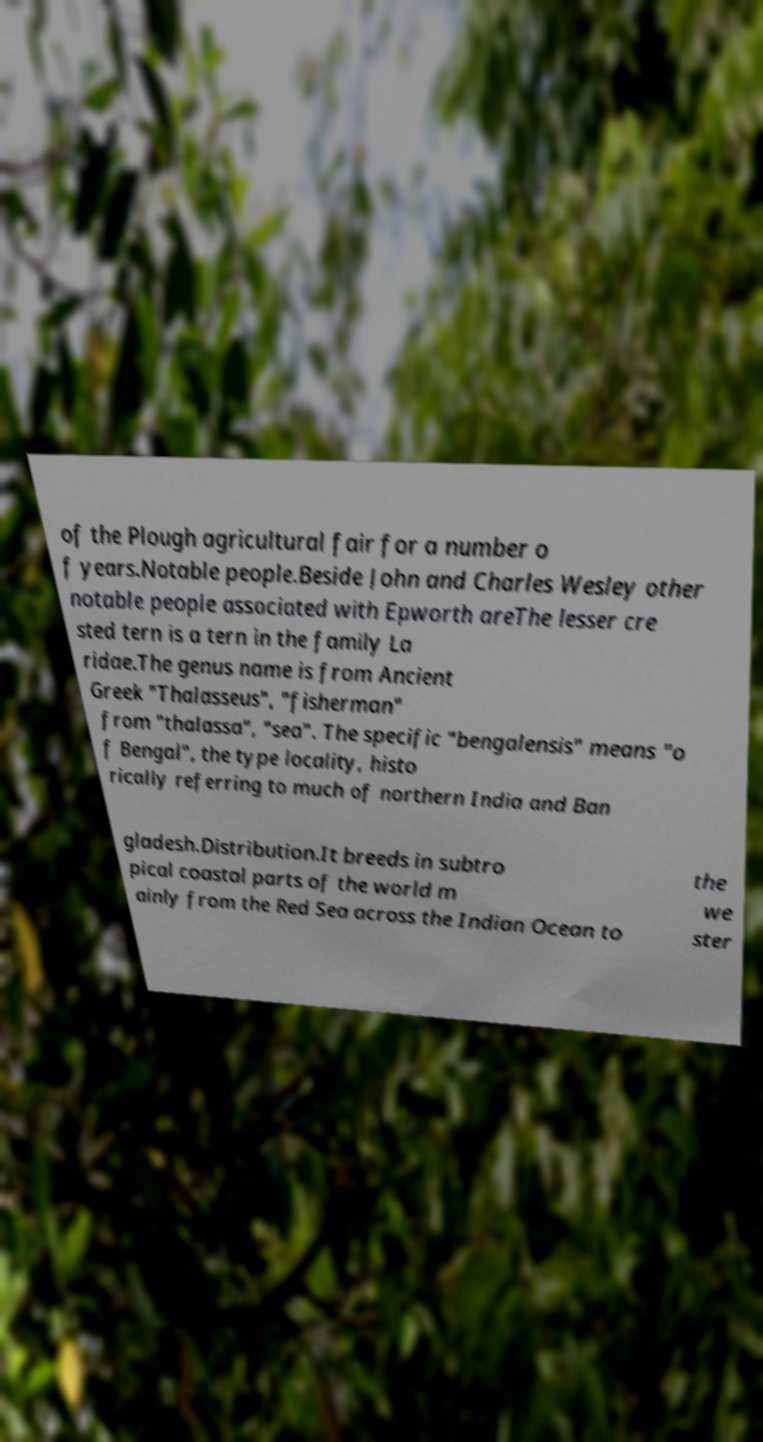Please read and relay the text visible in this image. What does it say? of the Plough agricultural fair for a number o f years.Notable people.Beside John and Charles Wesley other notable people associated with Epworth areThe lesser cre sted tern is a tern in the family La ridae.The genus name is from Ancient Greek "Thalasseus", "fisherman" from "thalassa", "sea". The specific "bengalensis" means "o f Bengal", the type locality, histo rically referring to much of northern India and Ban gladesh.Distribution.It breeds in subtro pical coastal parts of the world m ainly from the Red Sea across the Indian Ocean to the we ster 